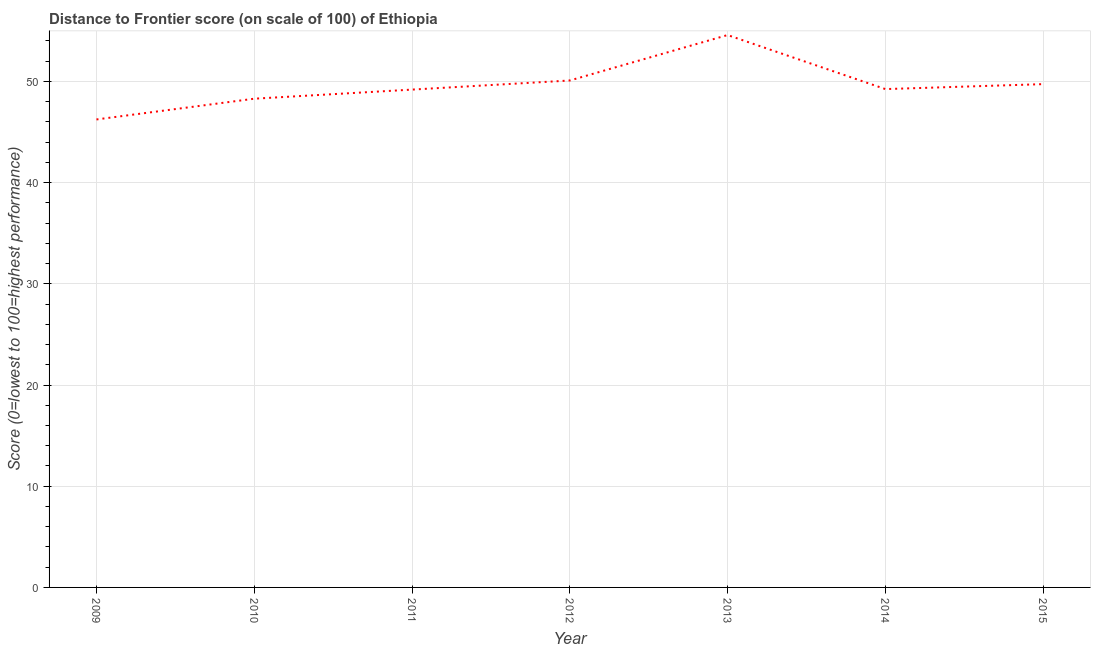What is the distance to frontier score in 2010?
Your answer should be compact. 48.29. Across all years, what is the maximum distance to frontier score?
Offer a terse response. 54.58. Across all years, what is the minimum distance to frontier score?
Offer a terse response. 46.24. In which year was the distance to frontier score maximum?
Your answer should be very brief. 2013. In which year was the distance to frontier score minimum?
Keep it short and to the point. 2009. What is the sum of the distance to frontier score?
Your answer should be compact. 347.36. What is the difference between the distance to frontier score in 2014 and 2015?
Give a very brief answer. -0.49. What is the average distance to frontier score per year?
Your response must be concise. 49.62. What is the median distance to frontier score?
Ensure brevity in your answer.  49.24. Do a majority of the years between 2012 and 2014 (inclusive) have distance to frontier score greater than 50 ?
Offer a terse response. Yes. What is the ratio of the distance to frontier score in 2009 to that in 2013?
Offer a very short reply. 0.85. Is the difference between the distance to frontier score in 2009 and 2012 greater than the difference between any two years?
Provide a succinct answer. No. What is the difference between the highest and the second highest distance to frontier score?
Provide a short and direct response. 4.49. What is the difference between the highest and the lowest distance to frontier score?
Your response must be concise. 8.34. In how many years, is the distance to frontier score greater than the average distance to frontier score taken over all years?
Make the answer very short. 3. What is the title of the graph?
Your response must be concise. Distance to Frontier score (on scale of 100) of Ethiopia. What is the label or title of the X-axis?
Provide a succinct answer. Year. What is the label or title of the Y-axis?
Your answer should be very brief. Score (0=lowest to 100=highest performance). What is the Score (0=lowest to 100=highest performance) in 2009?
Keep it short and to the point. 46.24. What is the Score (0=lowest to 100=highest performance) of 2010?
Make the answer very short. 48.29. What is the Score (0=lowest to 100=highest performance) in 2011?
Your answer should be compact. 49.19. What is the Score (0=lowest to 100=highest performance) of 2012?
Give a very brief answer. 50.09. What is the Score (0=lowest to 100=highest performance) of 2013?
Keep it short and to the point. 54.58. What is the Score (0=lowest to 100=highest performance) of 2014?
Your response must be concise. 49.24. What is the Score (0=lowest to 100=highest performance) in 2015?
Make the answer very short. 49.73. What is the difference between the Score (0=lowest to 100=highest performance) in 2009 and 2010?
Your answer should be very brief. -2.05. What is the difference between the Score (0=lowest to 100=highest performance) in 2009 and 2011?
Offer a terse response. -2.95. What is the difference between the Score (0=lowest to 100=highest performance) in 2009 and 2012?
Ensure brevity in your answer.  -3.85. What is the difference between the Score (0=lowest to 100=highest performance) in 2009 and 2013?
Give a very brief answer. -8.34. What is the difference between the Score (0=lowest to 100=highest performance) in 2009 and 2015?
Provide a succinct answer. -3.49. What is the difference between the Score (0=lowest to 100=highest performance) in 2010 and 2012?
Provide a short and direct response. -1.8. What is the difference between the Score (0=lowest to 100=highest performance) in 2010 and 2013?
Your answer should be very brief. -6.29. What is the difference between the Score (0=lowest to 100=highest performance) in 2010 and 2014?
Your response must be concise. -0.95. What is the difference between the Score (0=lowest to 100=highest performance) in 2010 and 2015?
Provide a succinct answer. -1.44. What is the difference between the Score (0=lowest to 100=highest performance) in 2011 and 2012?
Offer a very short reply. -0.9. What is the difference between the Score (0=lowest to 100=highest performance) in 2011 and 2013?
Give a very brief answer. -5.39. What is the difference between the Score (0=lowest to 100=highest performance) in 2011 and 2015?
Keep it short and to the point. -0.54. What is the difference between the Score (0=lowest to 100=highest performance) in 2012 and 2013?
Offer a very short reply. -4.49. What is the difference between the Score (0=lowest to 100=highest performance) in 2012 and 2014?
Provide a short and direct response. 0.85. What is the difference between the Score (0=lowest to 100=highest performance) in 2012 and 2015?
Give a very brief answer. 0.36. What is the difference between the Score (0=lowest to 100=highest performance) in 2013 and 2014?
Give a very brief answer. 5.34. What is the difference between the Score (0=lowest to 100=highest performance) in 2013 and 2015?
Provide a short and direct response. 4.85. What is the difference between the Score (0=lowest to 100=highest performance) in 2014 and 2015?
Ensure brevity in your answer.  -0.49. What is the ratio of the Score (0=lowest to 100=highest performance) in 2009 to that in 2010?
Keep it short and to the point. 0.96. What is the ratio of the Score (0=lowest to 100=highest performance) in 2009 to that in 2012?
Keep it short and to the point. 0.92. What is the ratio of the Score (0=lowest to 100=highest performance) in 2009 to that in 2013?
Your answer should be very brief. 0.85. What is the ratio of the Score (0=lowest to 100=highest performance) in 2009 to that in 2014?
Your response must be concise. 0.94. What is the ratio of the Score (0=lowest to 100=highest performance) in 2010 to that in 2013?
Your answer should be compact. 0.89. What is the ratio of the Score (0=lowest to 100=highest performance) in 2011 to that in 2013?
Keep it short and to the point. 0.9. What is the ratio of the Score (0=lowest to 100=highest performance) in 2011 to that in 2015?
Make the answer very short. 0.99. What is the ratio of the Score (0=lowest to 100=highest performance) in 2012 to that in 2013?
Provide a succinct answer. 0.92. What is the ratio of the Score (0=lowest to 100=highest performance) in 2013 to that in 2014?
Offer a very short reply. 1.11. What is the ratio of the Score (0=lowest to 100=highest performance) in 2013 to that in 2015?
Your response must be concise. 1.1. 